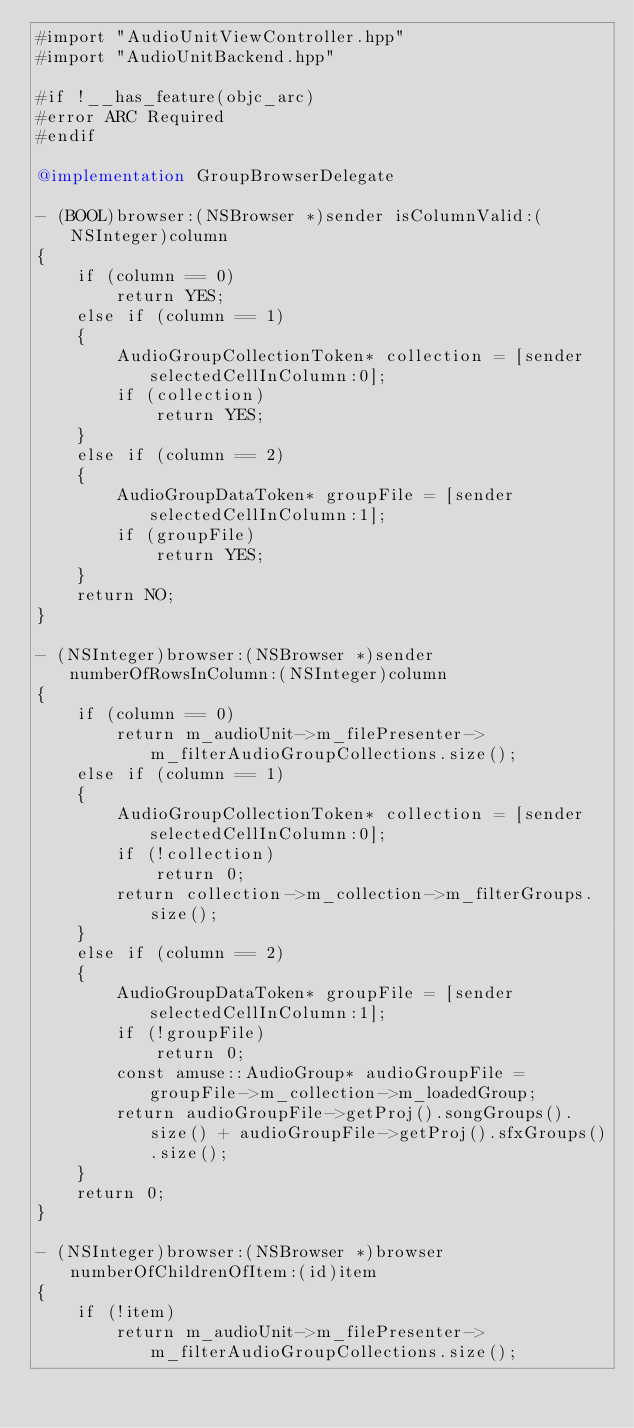<code> <loc_0><loc_0><loc_500><loc_500><_ObjectiveC_>#import "AudioUnitViewController.hpp"
#import "AudioUnitBackend.hpp"

#if !__has_feature(objc_arc)
#error ARC Required
#endif

@implementation GroupBrowserDelegate

- (BOOL)browser:(NSBrowser *)sender isColumnValid:(NSInteger)column
{
    if (column == 0)
        return YES;
    else if (column == 1)
    {
        AudioGroupCollectionToken* collection = [sender selectedCellInColumn:0];
        if (collection)
            return YES;
    }
    else if (column == 2)
    {
        AudioGroupDataToken* groupFile = [sender selectedCellInColumn:1];
        if (groupFile)
            return YES;
    }
    return NO;
}

- (NSInteger)browser:(NSBrowser *)sender numberOfRowsInColumn:(NSInteger)column
{
    if (column == 0)
        return m_audioUnit->m_filePresenter->m_filterAudioGroupCollections.size();
    else if (column == 1)
    {
        AudioGroupCollectionToken* collection = [sender selectedCellInColumn:0];
        if (!collection)
            return 0;
        return collection->m_collection->m_filterGroups.size();
    }
    else if (column == 2)
    {
        AudioGroupDataToken* groupFile = [sender selectedCellInColumn:1];
        if (!groupFile)
            return 0;
        const amuse::AudioGroup* audioGroupFile = groupFile->m_collection->m_loadedGroup;
        return audioGroupFile->getProj().songGroups().size() + audioGroupFile->getProj().sfxGroups().size();
    }
    return 0;
}

- (NSInteger)browser:(NSBrowser *)browser numberOfChildrenOfItem:(id)item
{
    if (!item)
        return m_audioUnit->m_filePresenter->m_filterAudioGroupCollections.size();</code> 